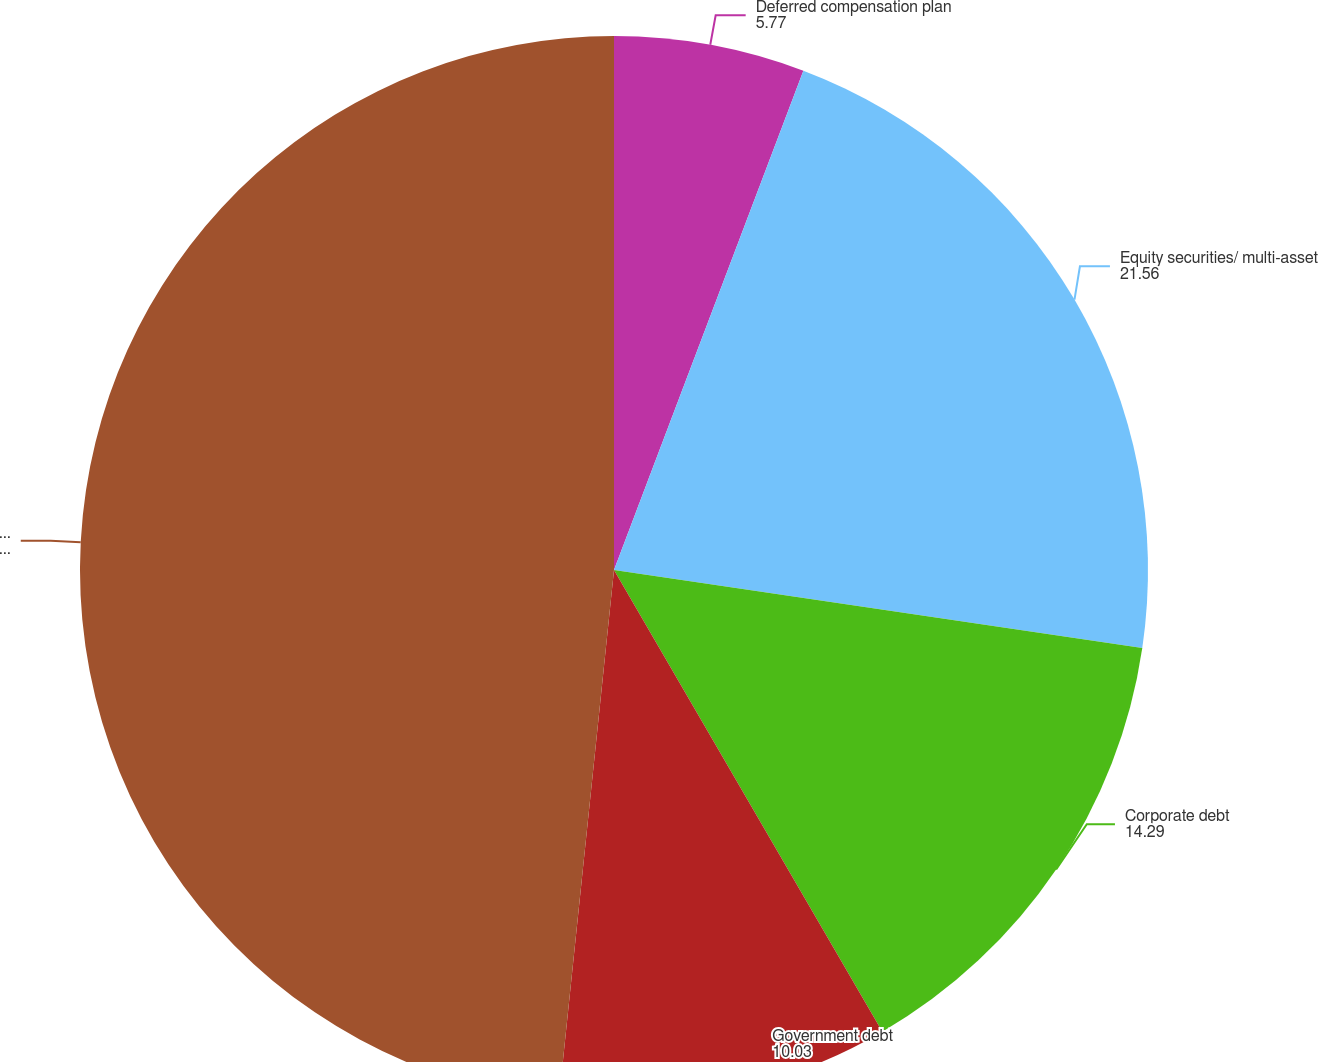Convert chart. <chart><loc_0><loc_0><loc_500><loc_500><pie_chart><fcel>Deferred compensation plan<fcel>Equity securities/ multi-asset<fcel>Corporate debt<fcel>Government debt<fcel>Total trading investments<nl><fcel>5.77%<fcel>21.56%<fcel>14.29%<fcel>10.03%<fcel>48.35%<nl></chart> 